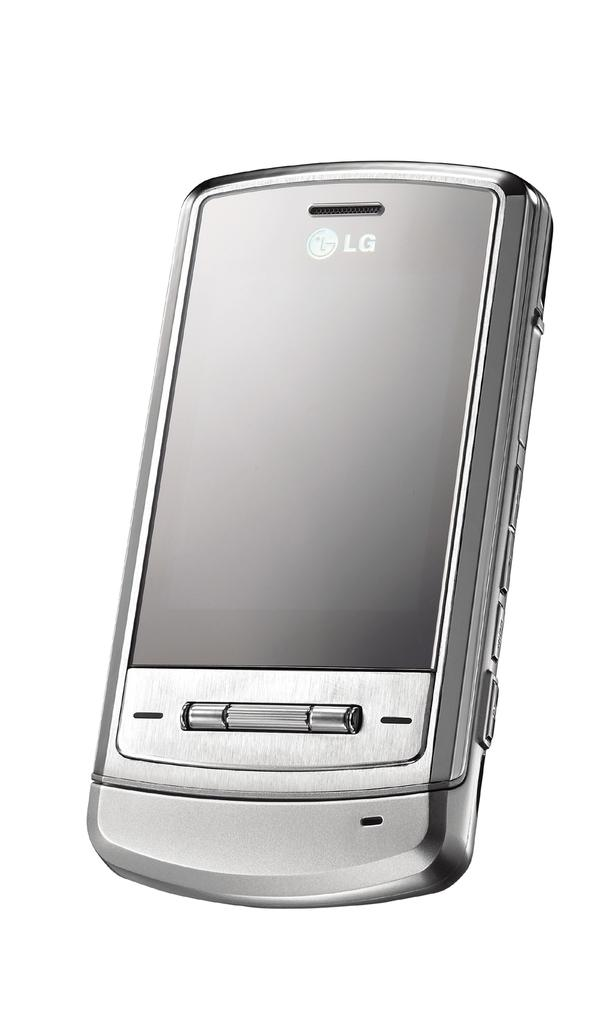<image>
Describe the image concisely. the word LG that is on the phone 